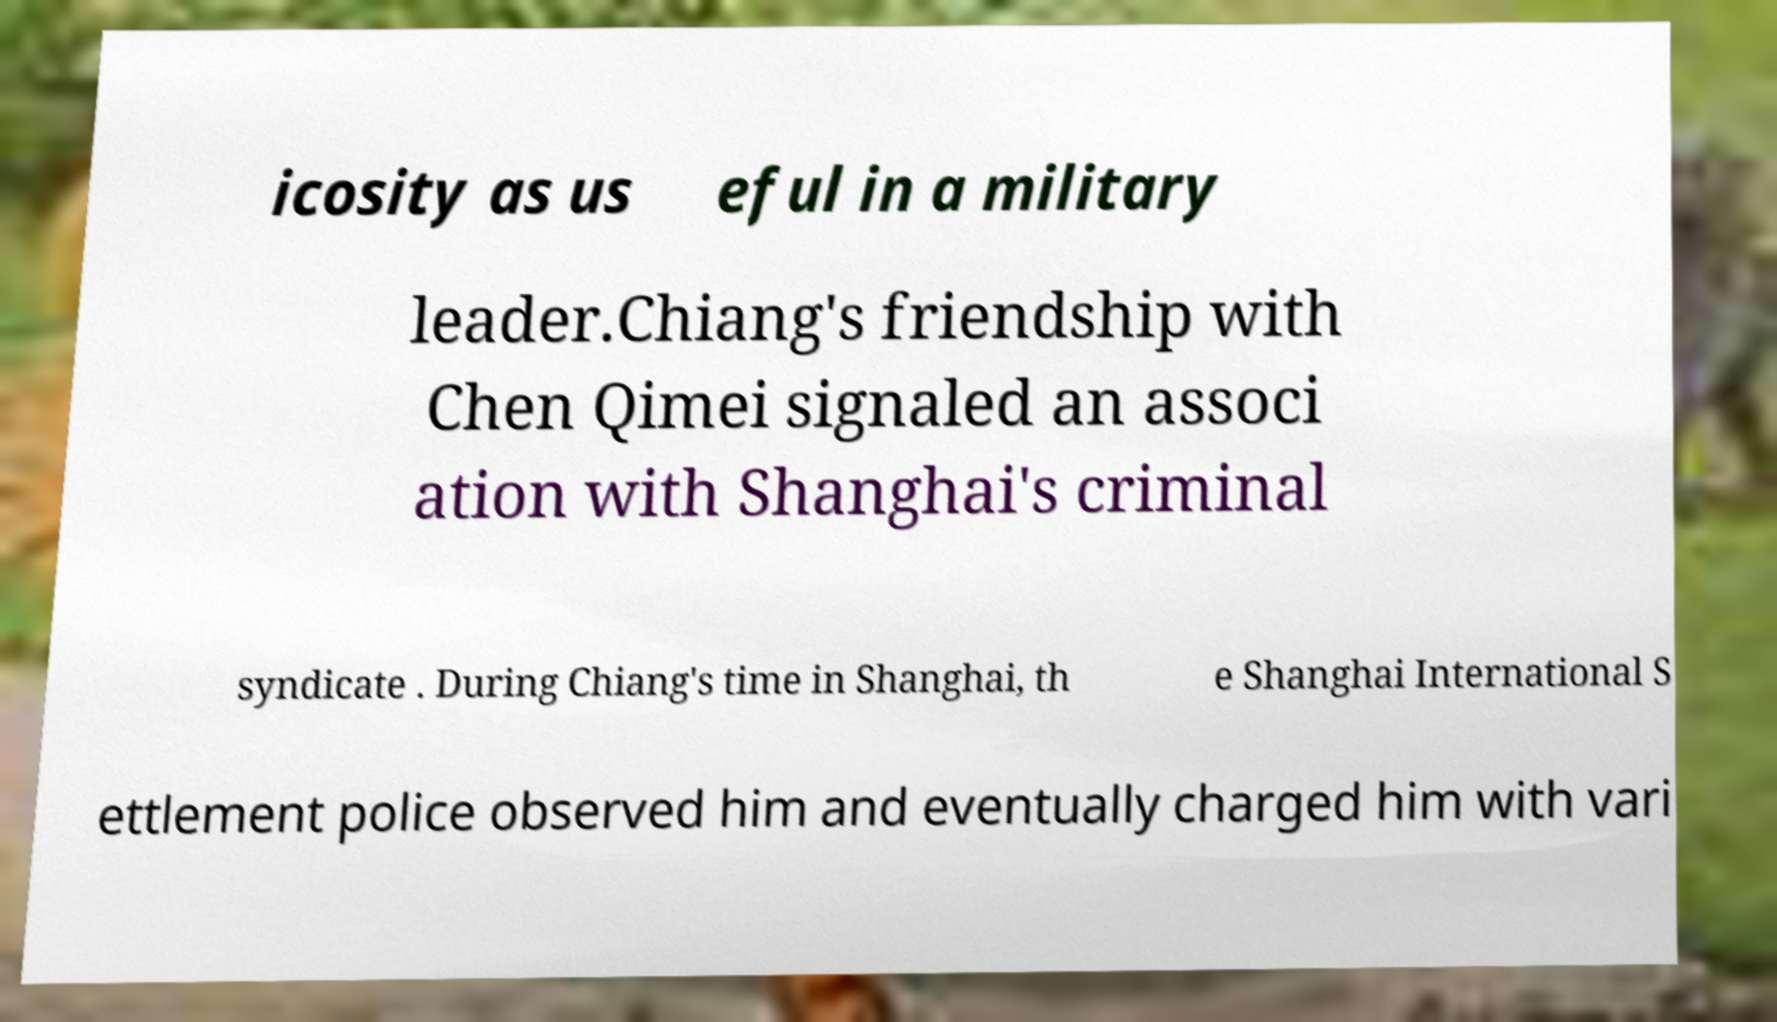Can you read and provide the text displayed in the image?This photo seems to have some interesting text. Can you extract and type it out for me? icosity as us eful in a military leader.Chiang's friendship with Chen Qimei signaled an associ ation with Shanghai's criminal syndicate . During Chiang's time in Shanghai, th e Shanghai International S ettlement police observed him and eventually charged him with vari 